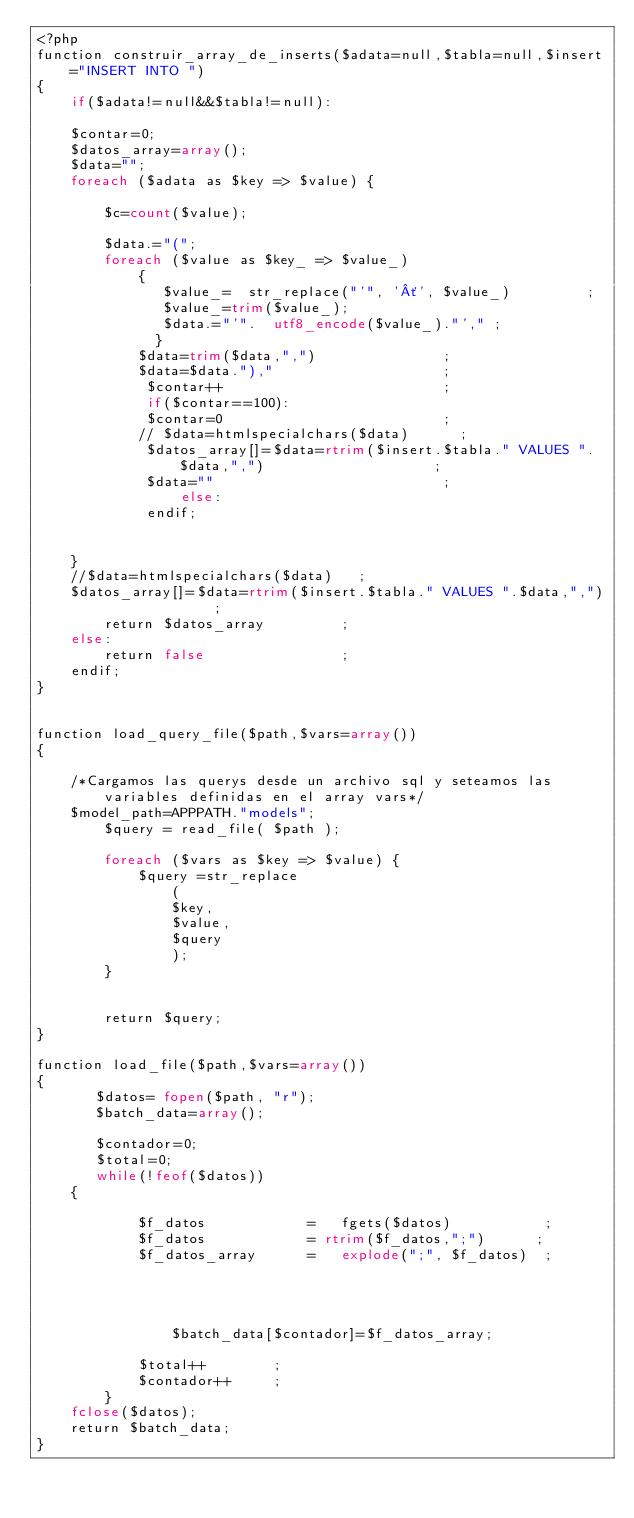<code> <loc_0><loc_0><loc_500><loc_500><_PHP_><?php
function construir_array_de_inserts($adata=null,$tabla=null,$insert="INSERT INTO ")
{
    if($adata!=null&&$tabla!=null):
        
    $contar=0;
    $datos_array=array();
    $data="";
    foreach ($adata as $key => $value) {
        
        $c=count($value);
        
        $data.="(";
        foreach ($value as $key_ => $value_) 
            {
               $value_=  str_replace("'", '´', $value_)         ;
               $value_=trim($value_);
               $data.="'".  utf8_encode($value_)."'," ;
              }
            $data=trim($data,",")               ;
            $data=$data."),"                    ;
             $contar++                          ;
             if($contar==100):
             $contar=0                          ;
            // $data=htmlspecialchars($data)      ;
             $datos_array[]=$data=rtrim($insert.$tabla." VALUES ".$data,",")                    ;
             $data=""                           ;
                 else:
             endif;
          
         
    }
    //$data=htmlspecialchars($data)   ;
    $datos_array[]=$data=rtrim($insert.$tabla." VALUES ".$data,",")             ;
        return $datos_array         ;
    else:
        return false                ;
    endif;
}


function load_query_file($path,$vars=array())
{
    
    /*Cargamos las querys desde un archivo sql y seteamos las variables definidas en el array vars*/
    $model_path=APPPATH."models";
        $query = read_file( $path );    
        
        foreach ($vars as $key => $value) {
            $query =str_replace
                (
                $key, 
                $value, 
                $query 
                );   
        }
        
        
        return $query;
}

function load_file($path,$vars=array())
{     
       $datos= fopen($path, "r");
       $batch_data=array();
       
       $contador=0;
       $total=0;
       while(!feof($datos))
	{
           
            $f_datos            =   fgets($datos)           ;
            $f_datos            = rtrim($f_datos,";")      ;
            $f_datos_array      =   explode(";", $f_datos)  ;
            
           
        
            
                $batch_data[$contador]=$f_datos_array;   
            
            $total++        ;
            $contador++     ;
        }
    fclose($datos);
    return $batch_data;
}
</code> 